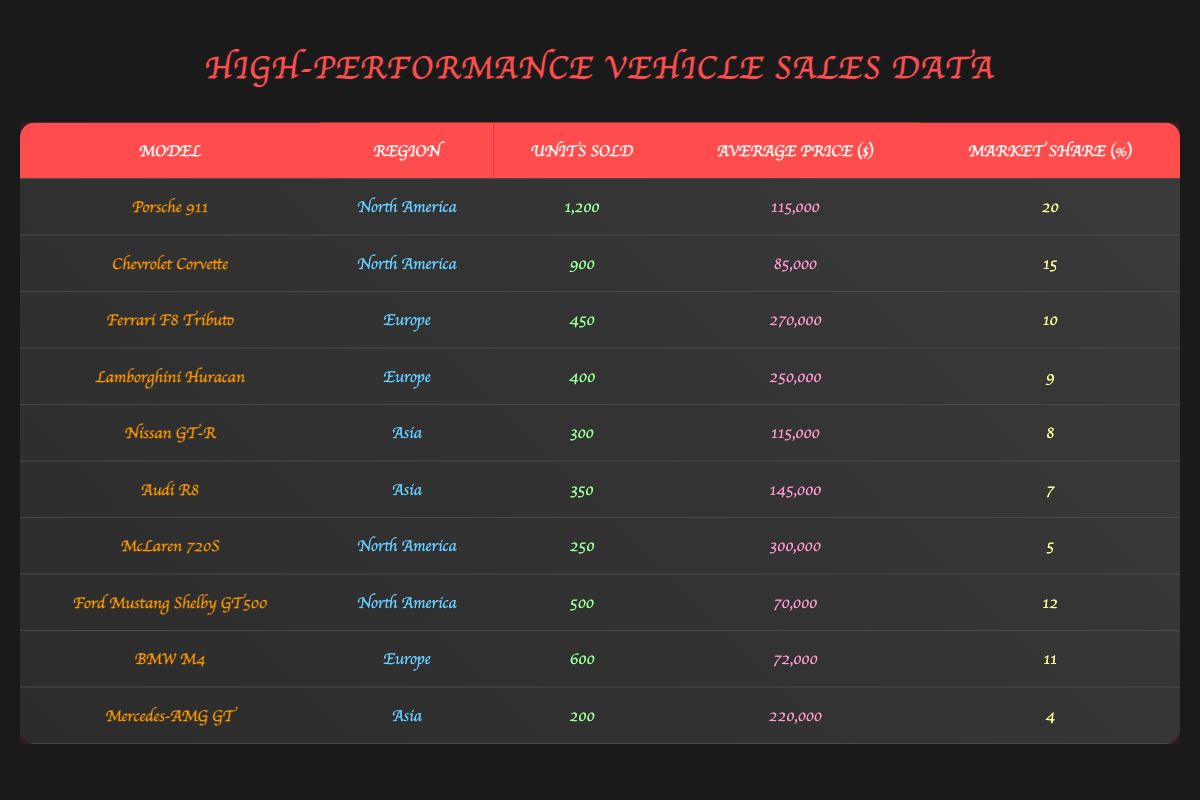What is the highest-selling model in North America? The table shows that the Porsche 911 has the highest units sold in North America at 1,200 units. Other models have lower sales figures.
Answer: Porsche 911 Which model has the highest average price in Europe? In the Europe region, the Ferrari F8 Tributo has the highest average price at 270,000 dollars, while the Lamborghini Huracan has 250,000 dollars.
Answer: Ferrari F8 Tributo What percentage of the market share does the Nissan GT-R have in Asia? From the table, the Nissan GT-R has a market share of 8 percent in the Asia region. This is clearly stated in its row.
Answer: 8 What is the total number of units sold across all high-performance vehicles in North America? To find the total, we sum the units sold from the North American models: 1200 (Porsche 911) + 900 (Chevrolet Corvette) + 250 (McLaren 720S) + 500 (Ford Mustang Shelby GT500) = 2850 units.
Answer: 2850 Is the Mercedes-AMG GT the lowest-selling vehicle in Asia? Yes, comparing the units sold of the two Asian models, the Mercedes-AMG GT sold 200 units, which is less than the Nissan GT-R (300 units) and the Audi R8 (350 units).
Answer: Yes Which vehicle has both a high average price and a low market share in North America? The McLaren 720S has a high average price of 300,000 dollars and a low market share of 5 percent, indicating it sold fewer units relative to its price.
Answer: McLaren 720S How does the market share of the Ford Mustang Shelby GT500 compare to that of the Chevrolet Corvette in North America? The Ford Mustang Shelby GT500 has a market share of 12 percent, whereas the Chevrolet Corvette has a market share of 15 percent. Therefore, the Corvette has a higher market share than the Mustang.
Answer: Chevrolet Corvette What is the average price of the Lamborghini Huracan and Ferrari F8 Tributo? Adding the average prices: 250,000 (Lamborghini Huracan) + 270,000 (Ferrari F8 Tributo) = 520,000 dollars. Then divide by 2 for the average: 520,000 / 2 = 260,000 dollars.
Answer: 260,000 Which region has the least number of high-performance vehicles sold overall? To assess, we can summarize the units sold in each region: North America (2850), Europe (1450), and Asia (850). Asia has the least with 850 units sold.
Answer: Asia 